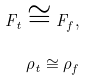Convert formula to latex. <formula><loc_0><loc_0><loc_500><loc_500>F _ { t } \cong F _ { f } , \\ \, \rho _ { t } \cong \rho _ { f }</formula> 